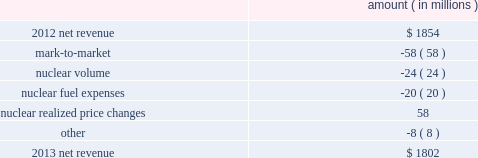The grand gulf recovery variance is primarily due to increased recovery of higher costs resulting from the grand gulf uprate .
The volume/weather variance is primarily due to the effects of more favorable weather on residential sales and an increase in industrial sales primarily due to growth in the refining segment .
The fuel recovery variance is primarily due to : 2022 the deferral of increased capacity costs that will be recovered through fuel adjustment clauses ; 2022 the expiration of the evangeline gas contract on january 1 , 2013 ; and 2022 an adjustment to deferred fuel costs recorded in the third quarter 2012 in accordance with a rate order from the puct issued in september 2012 .
See note 2 to the financial statements for further discussion of this puct order issued in entergy texas's 2011 rate case .
The miso deferral variance is primarily due to the deferral in april 2013 , as approved by the apsc , of costs incurred since march 2010 related to the transition and implementation of joining the miso rto .
The decommissioning trusts variance is primarily due to lower regulatory credits resulting from higher realized income on decommissioning trust fund investments .
There is no effect on net income as the credits are offset by interest and investment income .
Entergy wholesale commodities following is an analysis of the change in net revenue comparing 2013 to 2012 .
Amount ( in millions ) .
As shown in the table above , net revenue for entergy wholesale commodities decreased by approximately $ 52 million in 2013 primarily due to : 2022 the effect of rising forward power prices on electricity derivative instruments that are not designated as hedges , including additional financial power sales conducted in the fourth quarter 2013 to offset the planned exercise of in-the-money protective call options and to lock in margins .
These additional sales did not qualify for hedge accounting treatment , and increases in forward prices after those sales were made accounted for the majority of the negative mark-to-market variance .
It is expected that the underlying transactions will result in earnings in first quarter 2014 as these positions settle .
See note 16 to the financial statements for discussion of derivative instruments ; 2022 the decrease in net revenue compared to prior year resulting from the exercise of resupply options provided for in purchase power agreements where entergy wholesale commodities may elect to supply power from another source when the plant is not running .
Amounts related to the exercise of resupply options are included in the gwh billed in the table below ; and entergy corporation and subsidiaries management's financial discussion and analysis .
What are the nuclear fuel expenses as a percentage of the decrease in net revenue from 2012 to 2013? 
Computations: (20 / (1854 - 1802))
Answer: 0.38462. 